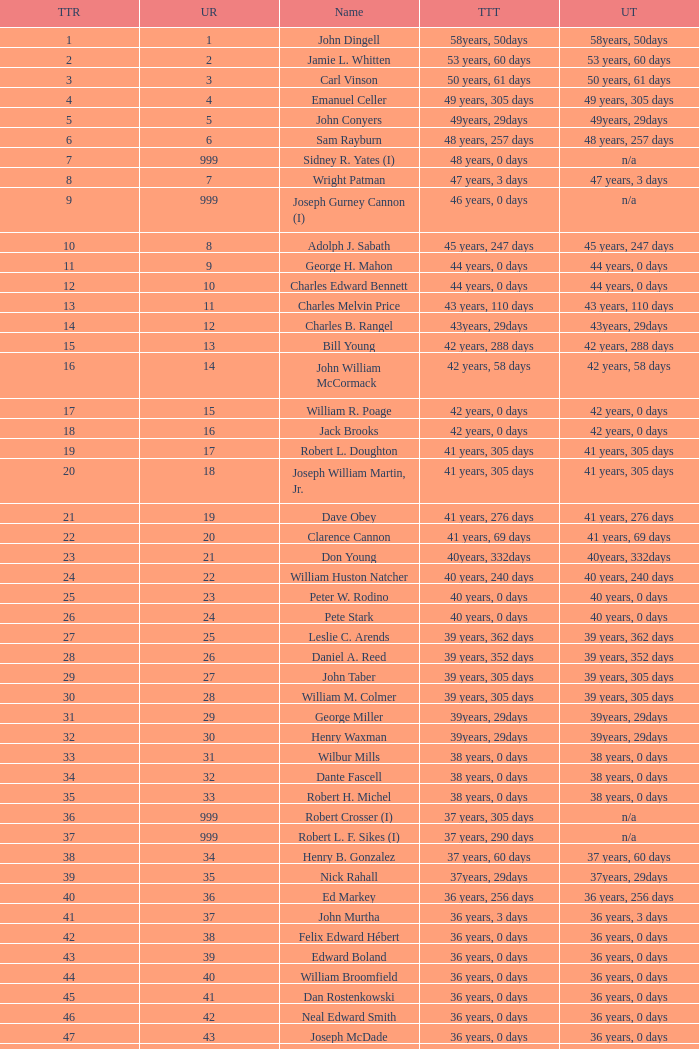Who has a total tenure time and uninterrupted time of 36 years, 0 days, as well as a total tenure rank of 49? James Oberstar. 